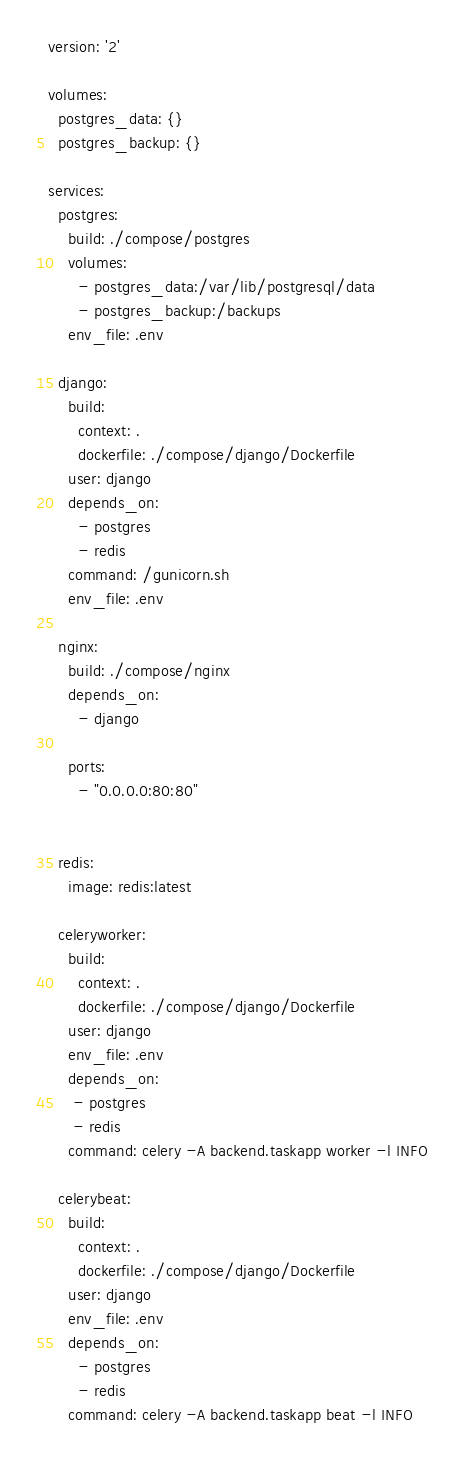<code> <loc_0><loc_0><loc_500><loc_500><_YAML_>version: '2'

volumes:
  postgres_data: {}
  postgres_backup: {}

services:
  postgres:
    build: ./compose/postgres
    volumes:
      - postgres_data:/var/lib/postgresql/data
      - postgres_backup:/backups
    env_file: .env

  django:
    build:
      context: .
      dockerfile: ./compose/django/Dockerfile
    user: django
    depends_on:
      - postgres
      - redis
    command: /gunicorn.sh
    env_file: .env

  nginx:
    build: ./compose/nginx
    depends_on:
      - django

    ports:
      - "0.0.0.0:80:80"


  redis:
    image: redis:latest

  celeryworker:
    build:
      context: .
      dockerfile: ./compose/django/Dockerfile
    user: django
    env_file: .env
    depends_on:
     - postgres
     - redis
    command: celery -A backend.taskapp worker -l INFO

  celerybeat:
    build:
      context: .
      dockerfile: ./compose/django/Dockerfile
    user: django
    env_file: .env
    depends_on:
      - postgres
      - redis
    command: celery -A backend.taskapp beat -l INFO

</code> 